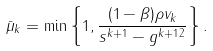<formula> <loc_0><loc_0><loc_500><loc_500>\bar { \mu } _ { k } = \min \left \{ 1 , \frac { ( 1 - \beta ) \rho v _ { k } } { \| s ^ { k + 1 } - g ^ { k + 1 } \| ^ { 2 } } \right \} .</formula> 